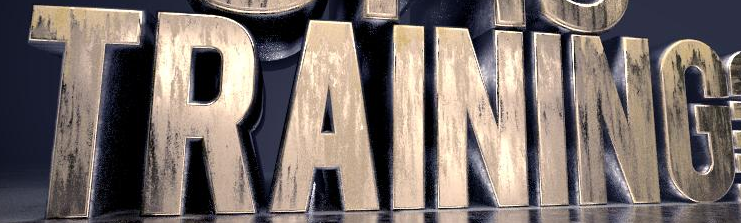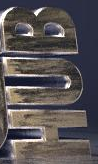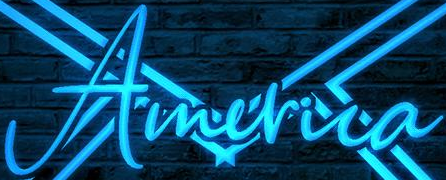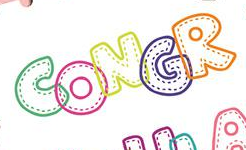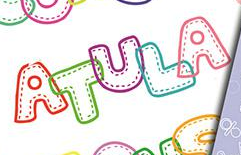Identify the words shown in these images in order, separated by a semicolon. TRAINING; HUB; America; CONGR; ATULA 